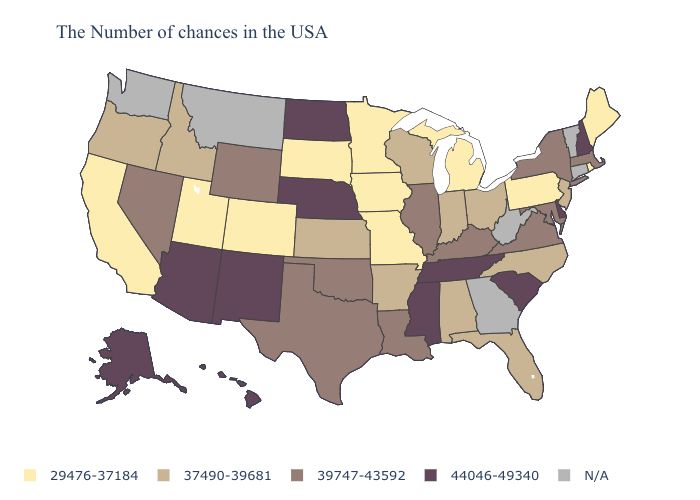What is the highest value in states that border Arizona?
Quick response, please. 44046-49340. Among the states that border Kansas , which have the lowest value?
Be succinct. Missouri, Colorado. How many symbols are there in the legend?
Be succinct. 5. What is the value of Massachusetts?
Short answer required. 39747-43592. What is the highest value in states that border New Hampshire?
Keep it brief. 39747-43592. Name the states that have a value in the range 39747-43592?
Answer briefly. Massachusetts, New York, Maryland, Virginia, Kentucky, Illinois, Louisiana, Oklahoma, Texas, Wyoming, Nevada. Name the states that have a value in the range N/A?
Concise answer only. Vermont, Connecticut, West Virginia, Georgia, Montana, Washington. Name the states that have a value in the range N/A?
Be succinct. Vermont, Connecticut, West Virginia, Georgia, Montana, Washington. What is the value of Nevada?
Write a very short answer. 39747-43592. What is the value of New York?
Give a very brief answer. 39747-43592. Name the states that have a value in the range N/A?
Quick response, please. Vermont, Connecticut, West Virginia, Georgia, Montana, Washington. What is the value of California?
Give a very brief answer. 29476-37184. Name the states that have a value in the range 39747-43592?
Write a very short answer. Massachusetts, New York, Maryland, Virginia, Kentucky, Illinois, Louisiana, Oklahoma, Texas, Wyoming, Nevada. 